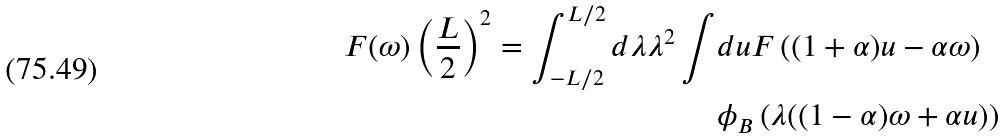Convert formula to latex. <formula><loc_0><loc_0><loc_500><loc_500>F ( \omega ) \left ( \frac { L } { 2 } \right ) ^ { 2 } = \int _ { - L / 2 } ^ { L / 2 } d \lambda \lambda ^ { 2 } \int & d u F \left ( ( 1 + \alpha ) u - \alpha \omega \right ) \\ & \phi _ { B } \left ( \lambda ( ( 1 - \alpha ) \omega + \alpha u ) \right )</formula> 